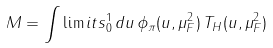<formula> <loc_0><loc_0><loc_500><loc_500>M = \int \lim i t s _ { 0 } ^ { 1 } \, d u \, \phi _ { \pi } ( u , \mu ^ { 2 } _ { F } ) \, T _ { H } ( u , \mu _ { F } ^ { 2 } )</formula> 